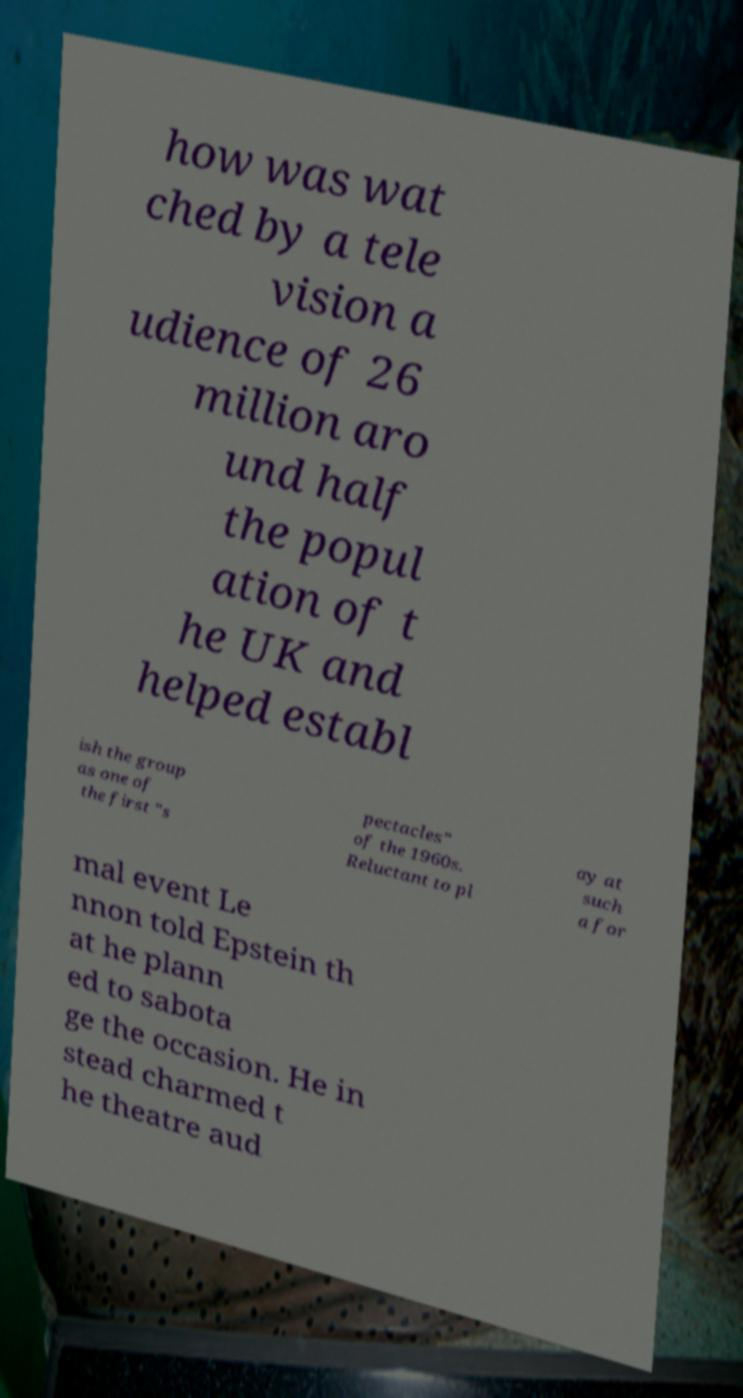Can you read and provide the text displayed in the image?This photo seems to have some interesting text. Can you extract and type it out for me? how was wat ched by a tele vision a udience of 26 million aro und half the popul ation of t he UK and helped establ ish the group as one of the first "s pectacles" of the 1960s. Reluctant to pl ay at such a for mal event Le nnon told Epstein th at he plann ed to sabota ge the occasion. He in stead charmed t he theatre aud 